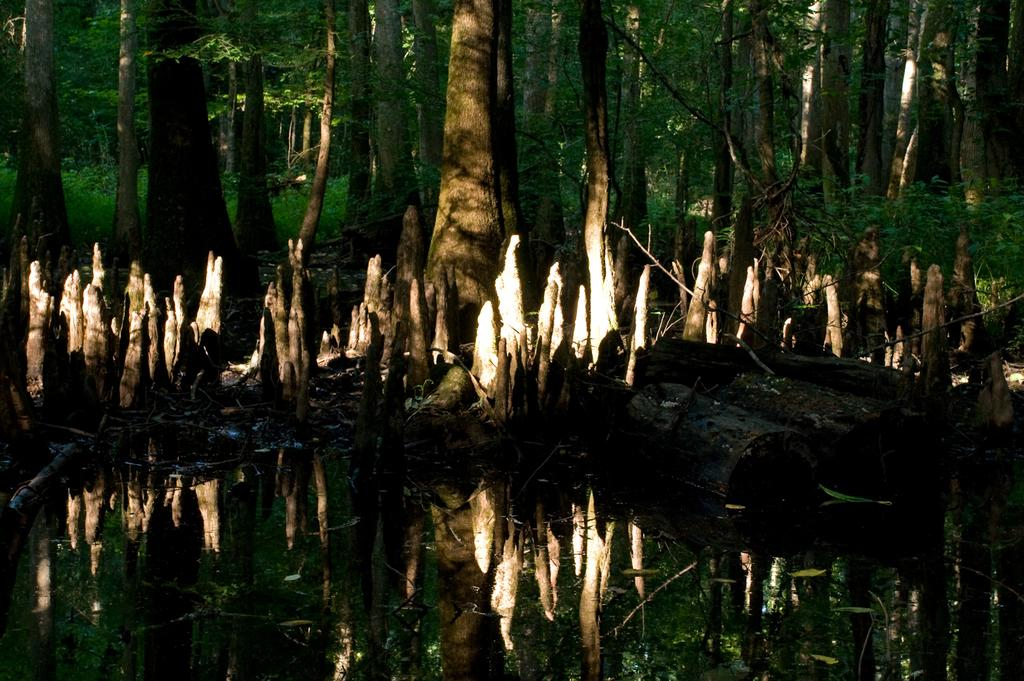What type of body of water is present in the image? There is a pond in the image. What other natural elements can be seen in the image? There are trees in the image. What type of coach can be seen driving through the pond in the image? There is no coach present in the image, and the pond is not a road for vehicles to drive through. 